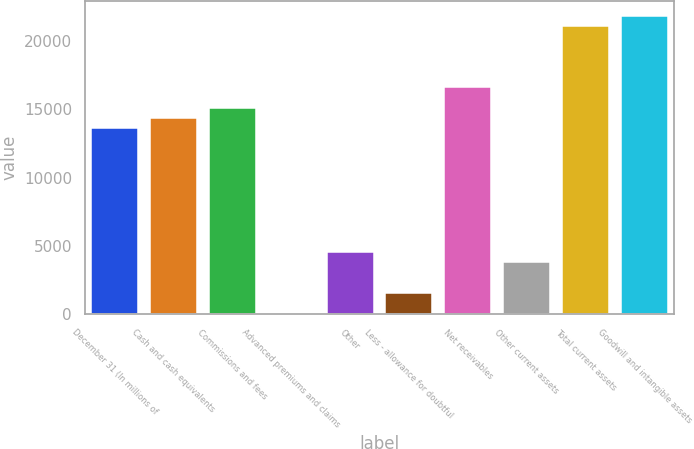Convert chart to OTSL. <chart><loc_0><loc_0><loc_500><loc_500><bar_chart><fcel>December 31 (In millions of<fcel>Cash and cash equivalents<fcel>Commissions and fees<fcel>Advanced premiums and claims<fcel>Other<fcel>Less - allowance for doubtful<fcel>Net receivables<fcel>Other current assets<fcel>Total current assets<fcel>Goodwill and intangible assets<nl><fcel>13605.4<fcel>14356.7<fcel>15108<fcel>82<fcel>4589.8<fcel>1584.6<fcel>16610.6<fcel>3838.5<fcel>21118.4<fcel>21869.7<nl></chart> 